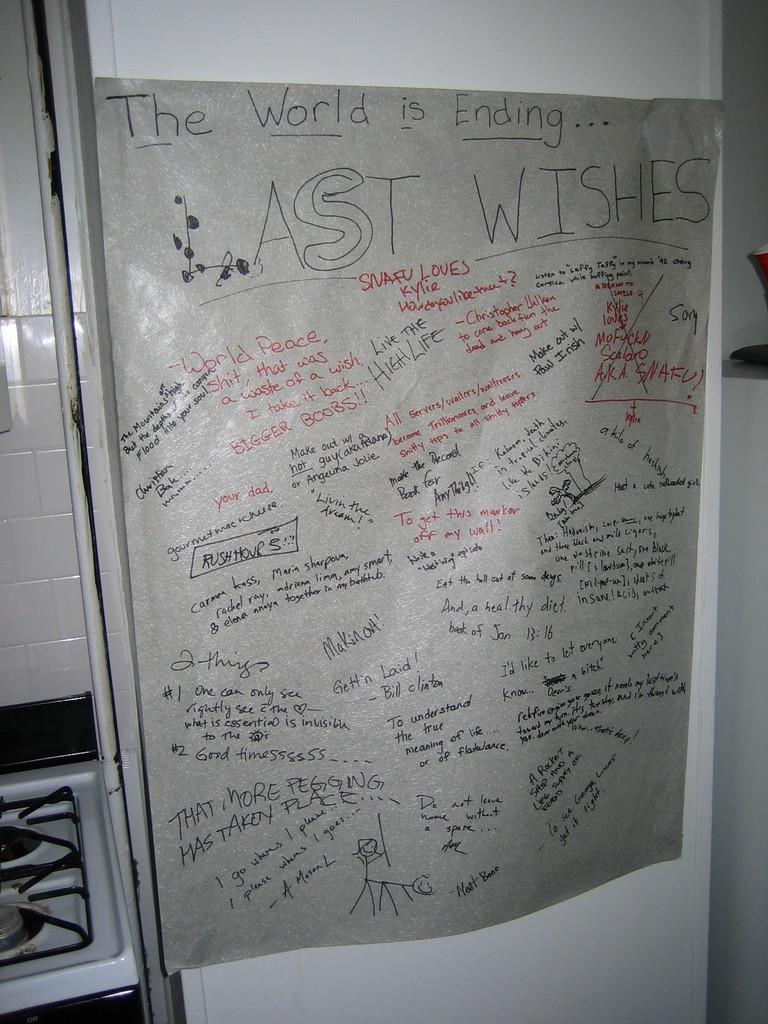Please provide a concise description of this image. On a white background there is a paper on which something is written. There is a stove at the left. 